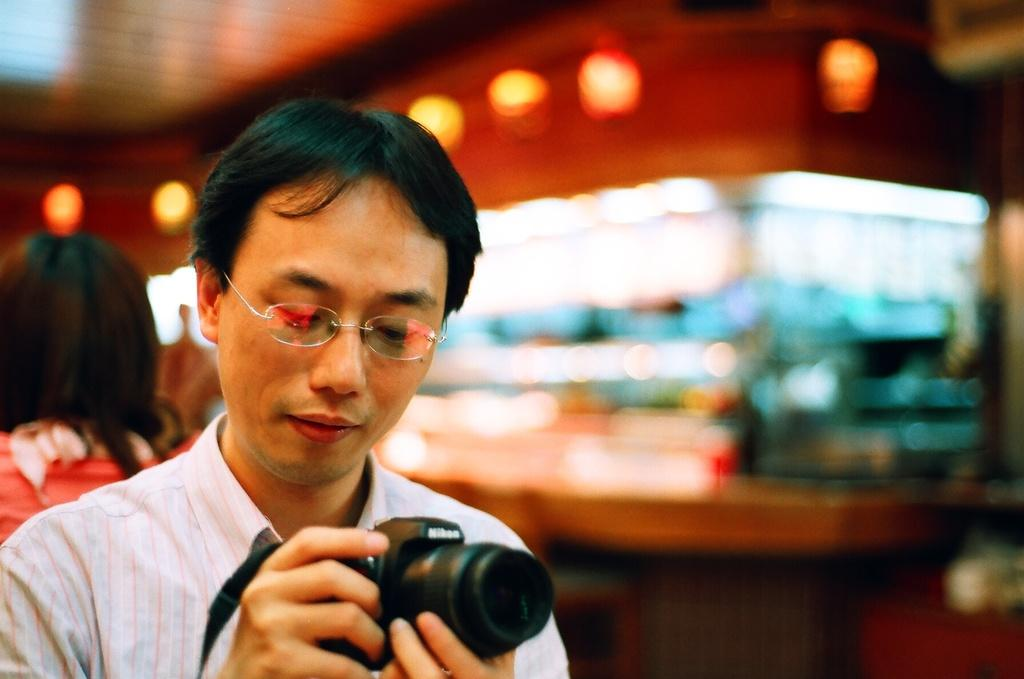How many people are in the image? There are two persons in the image. What is one of the persons doing in the image? One of the persons, a man, is holding a camera. Can you describe the man's appearance? The man is wearing glasses (specs). What else can be seen in the image besides the people? There are lights visible in the image. What type of monkey is sitting on the man's shoulder in the image? There is no monkey present in the image; only the man holding a camera and wearing glasses can be seen. How many toes does the man have on his left foot in the image? The image does not show the man's toes, so it is not possible to determine the number of toes on his left foot. 